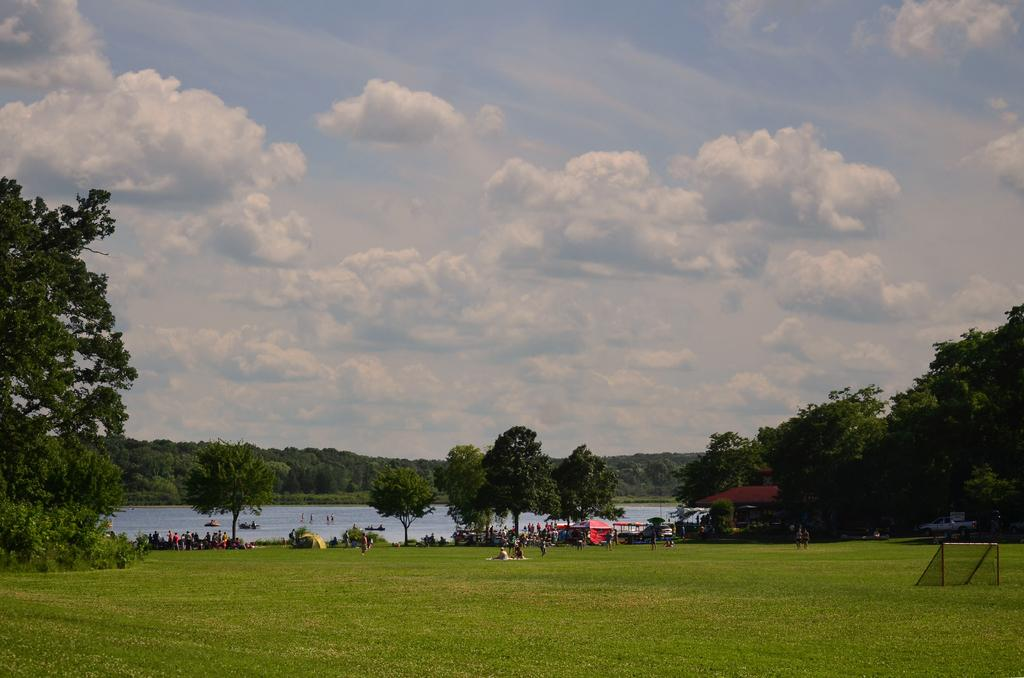What type of vegetation is present in the image? There is grass and trees in the image. Are there any people in the image? Yes, there are persons in the image. What type of vehicle is visible in the image? There is a car in the image. What type of temporary shelter is present in the image? There are tents in the image. What can be seen in the background of the image? Water, trees, and the sky are visible in the background. What type of downtown area is visible in the image? There is no downtown area present in the image. How many passengers are in the car in the image? The image does not show the inside of the car, so it is impossible to determine the number of passengers. 